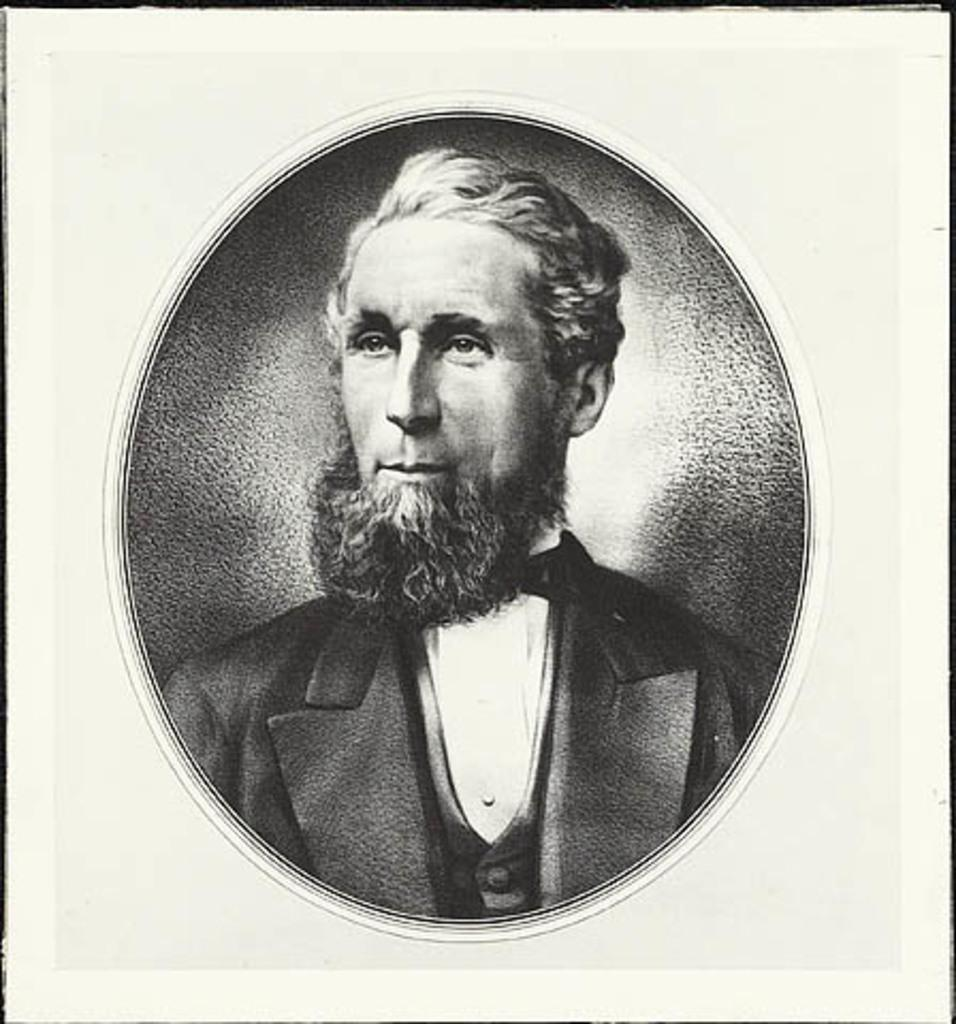What is the main object in the image? There is a frame in the image. What can be seen inside the frame? The image inside the frame is in black and white. What is the subject of the black and white image? The image inside the frame is of a man. How many bikes are visible in the image? There are no bikes present in the image. What type of cream is being used to decorate the man's face in the image? There is no cream or decoration on the man's face in the image. 